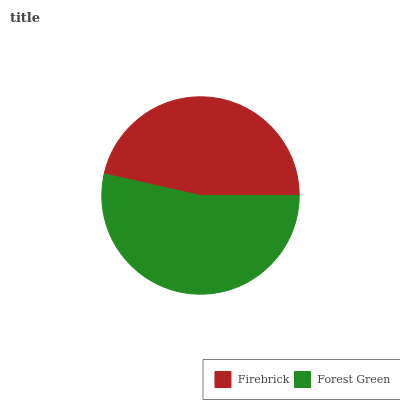Is Firebrick the minimum?
Answer yes or no. Yes. Is Forest Green the maximum?
Answer yes or no. Yes. Is Forest Green the minimum?
Answer yes or no. No. Is Forest Green greater than Firebrick?
Answer yes or no. Yes. Is Firebrick less than Forest Green?
Answer yes or no. Yes. Is Firebrick greater than Forest Green?
Answer yes or no. No. Is Forest Green less than Firebrick?
Answer yes or no. No. Is Forest Green the high median?
Answer yes or no. Yes. Is Firebrick the low median?
Answer yes or no. Yes. Is Firebrick the high median?
Answer yes or no. No. Is Forest Green the low median?
Answer yes or no. No. 